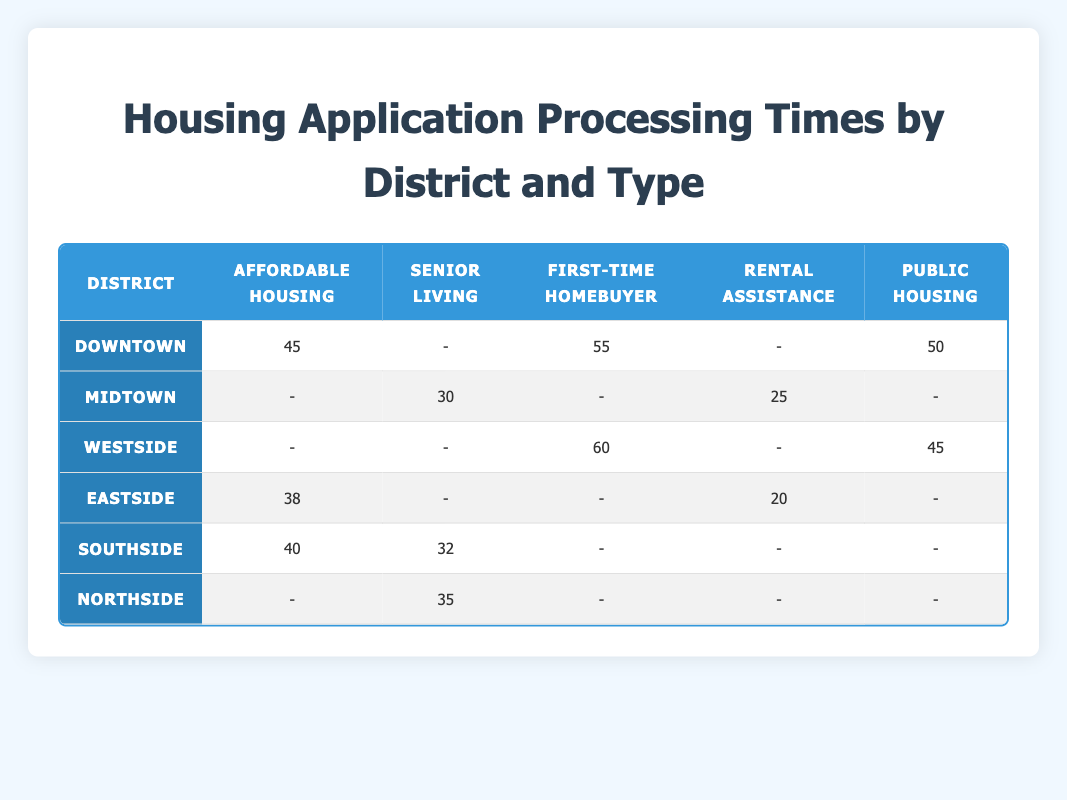What is the processing time for Affordable Housing applications in Downtown? The table shows that for the Affordable Housing application type in the Downtown district, the processing time is 45 days.
Answer: 45 days Which district has the shortest processing time for Senior Living applications? Referring to the Senior Living column, Midtown has a processing time of 30 days, which is the shortest among all districts listed.
Answer: Midtown What is the average processing time for First-Time Homebuyer applications across all districts? For First-Time Homebuyer applications, the processing times are 55 (Downtown), 60 (Westside). Average = (55 + 60) / 2 = 57.5 days.
Answer: 57.5 days Is there a district that has no processing time listed for Rental Assistance applications? From the table, the districts without any processing time listed for Rental Assistance are Downtown and Westside, confirming that it is true.
Answer: Yes What is the difference in processing time for Public Housing applications between Downtown and Westside? For Public Housing, Downtown has a processing time of 50 days, while Westside has 45 days. The difference is 50 - 45 = 5 days.
Answer: 5 days Which application type has the highest processing time in the Eastside district? In the Eastside district, the application types listed are Affordable Housing (38 days) and Rental Assistance (20 days). The highest processing time is for Affordable Housing at 38 days.
Answer: Affordable Housing What is the total processing time for all Affordable Housing applications across districts? The Affordable Housing processing times are 45 (Downtown) + 40 (Southside) + 38 (Eastside) = 123 days total for all districts combined.
Answer: 123 days How many districts have a processing time for both Senior Living and Public Housing applications? The districts with Senior Living applications are Midtown and Northside. The only district with Public Housing applications is Downtown and Westside. Only Southside has both Senior Living (32 days) and Public Housing entries but does not apply. Overall, only one (Southside). Thus the total is two unique districts.
Answer: Two districts What is the highest processing time recorded for any application type across all districts? The highest processing times found are 60 for First-Time Homebuyer in Westside, thus that is the highest across all districts and application types.
Answer: 60 days 